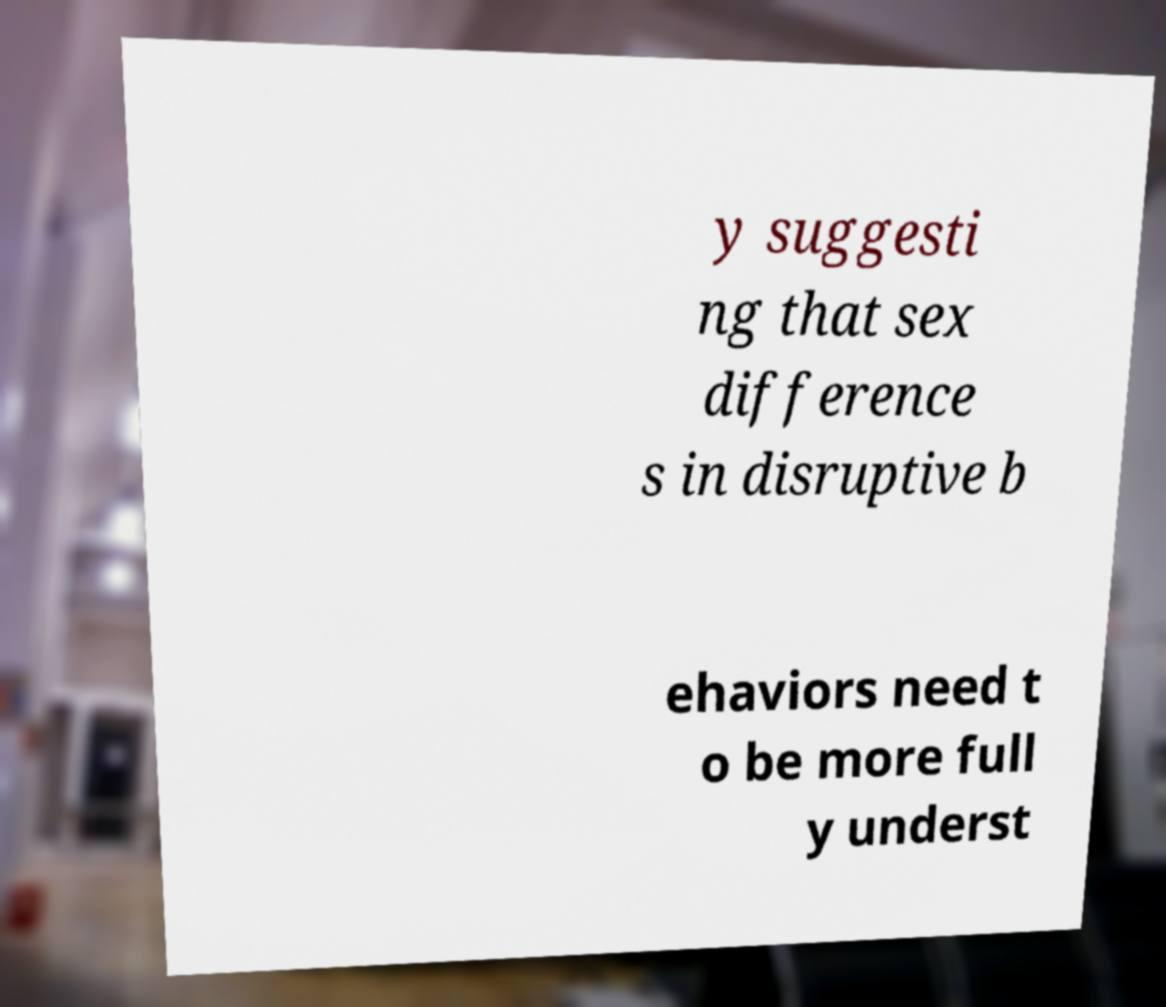I need the written content from this picture converted into text. Can you do that? y suggesti ng that sex difference s in disruptive b ehaviors need t o be more full y underst 